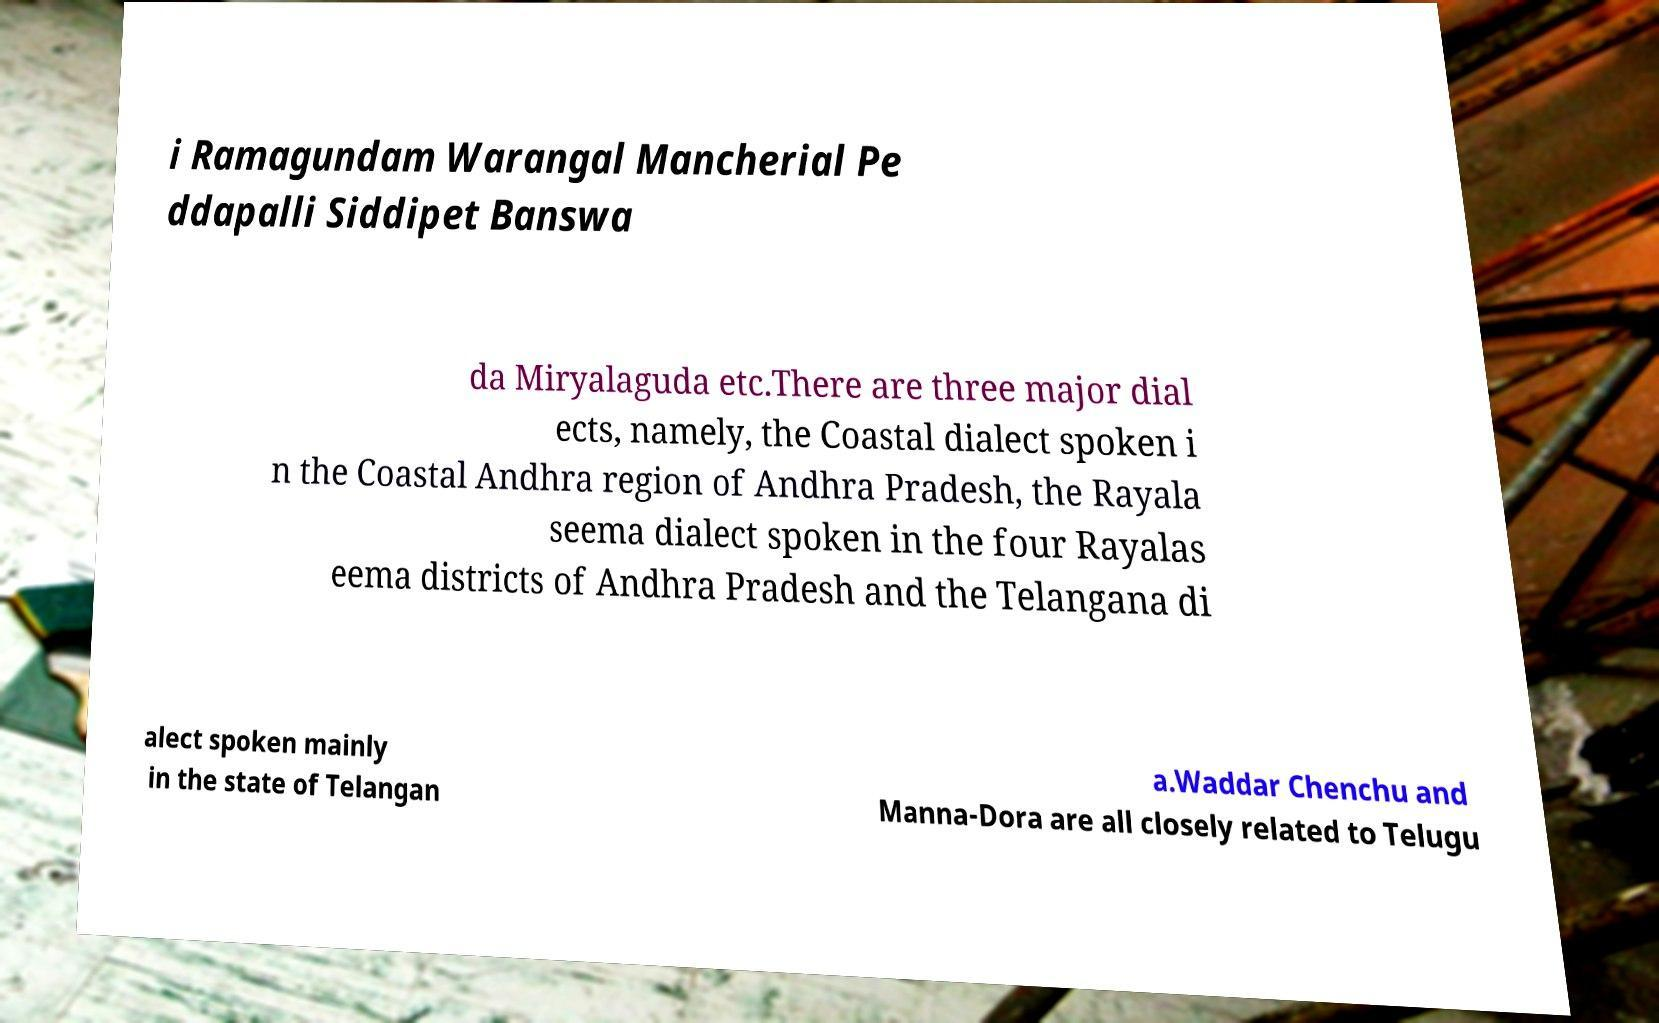Please read and relay the text visible in this image. What does it say? i Ramagundam Warangal Mancherial Pe ddapalli Siddipet Banswa da Miryalaguda etc.There are three major dial ects, namely, the Coastal dialect spoken i n the Coastal Andhra region of Andhra Pradesh, the Rayala seema dialect spoken in the four Rayalas eema districts of Andhra Pradesh and the Telangana di alect spoken mainly in the state of Telangan a.Waddar Chenchu and Manna-Dora are all closely related to Telugu 